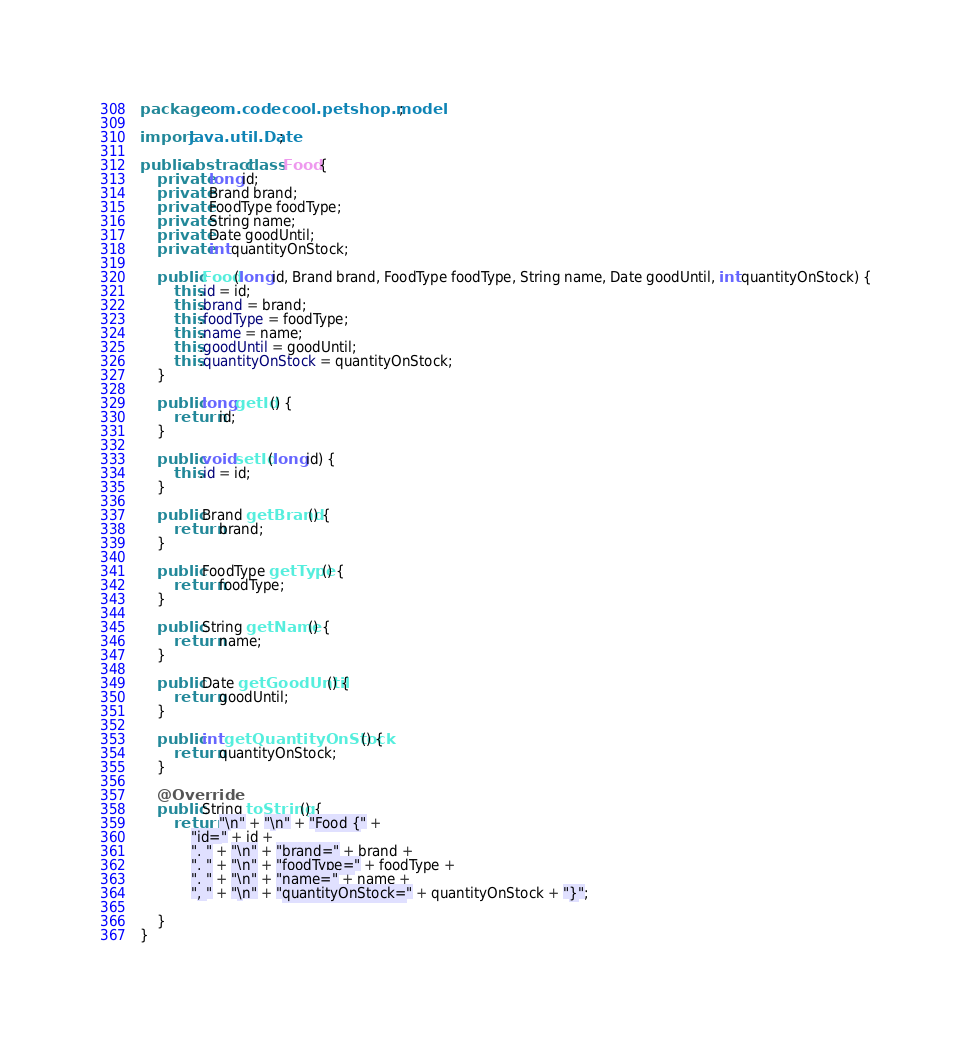<code> <loc_0><loc_0><loc_500><loc_500><_Java_>package com.codecool.petshop.model;

import java.util.Date;

public abstract class Food {
    private long id;
    private Brand brand;
    private FoodType foodType;
    private String name;
    private Date goodUntil;
    private int quantityOnStock;

    public Food(long id, Brand brand, FoodType foodType, String name, Date goodUntil, int quantityOnStock) {
        this.id = id;
        this.brand = brand;
        this.foodType = foodType;
        this.name = name;
        this.goodUntil = goodUntil;
        this.quantityOnStock = quantityOnStock;
    }

    public long getId() {
        return id;
    }

    public void setId(long id) {
        this.id = id;
    }

    public Brand getBrand() {
        return brand;
    }

    public FoodType getType() {
        return foodType;
    }

    public String getName() {
        return name;
    }

    public Date getGoodUntil() {
        return goodUntil;
    }

    public int getQuantityOnStock() {
        return quantityOnStock;
    }

    @Override
    public String toString() {
        return "\n" + "\n" + "Food {" +
            "id=" + id +
            ", " + "\n" + "brand=" + brand +
            ", " + "\n" + "foodType=" + foodType +
            ", " + "\n" + "name=" + name +
            ", " + "\n" + "quantityOnStock=" + quantityOnStock + "}";

    }
}
</code> 